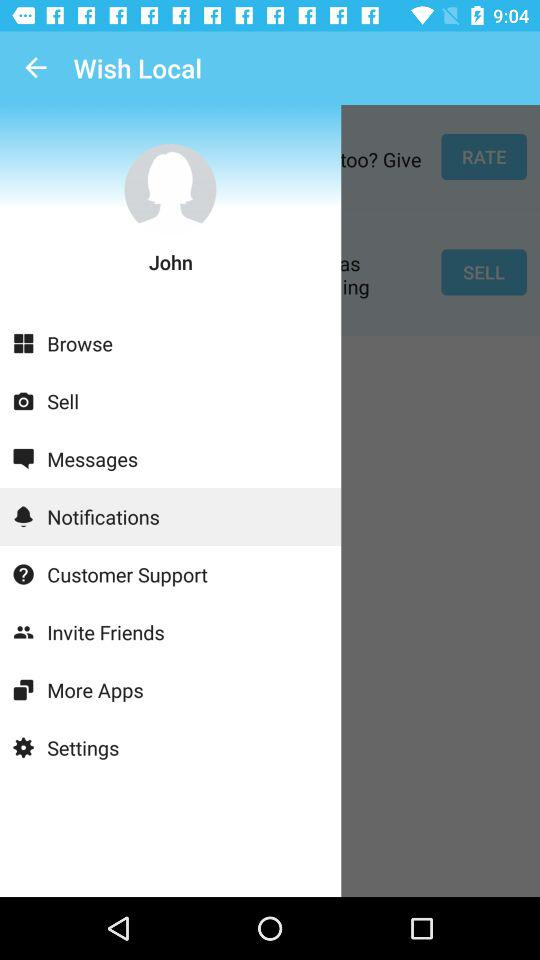How old is "John"?
When the provided information is insufficient, respond with <no answer>. <no answer> 